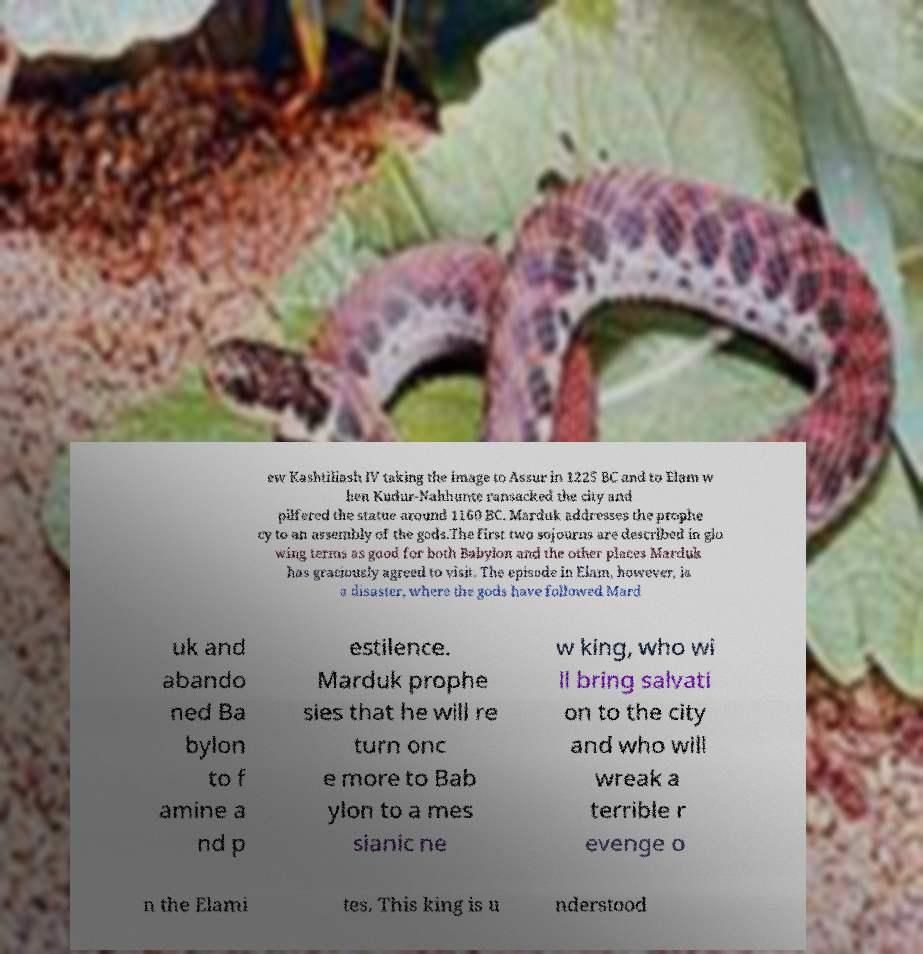Could you assist in decoding the text presented in this image and type it out clearly? ew Kashtiliash IV taking the image to Assur in 1225 BC and to Elam w hen Kudur-Nahhunte ransacked the city and pilfered the statue around 1160 BC. Marduk addresses the prophe cy to an assembly of the gods.The first two sojourns are described in glo wing terms as good for both Babylon and the other places Marduk has graciously agreed to visit. The episode in Elam, however, is a disaster, where the gods have followed Mard uk and abando ned Ba bylon to f amine a nd p estilence. Marduk prophe sies that he will re turn onc e more to Bab ylon to a mes sianic ne w king, who wi ll bring salvati on to the city and who will wreak a terrible r evenge o n the Elami tes. This king is u nderstood 